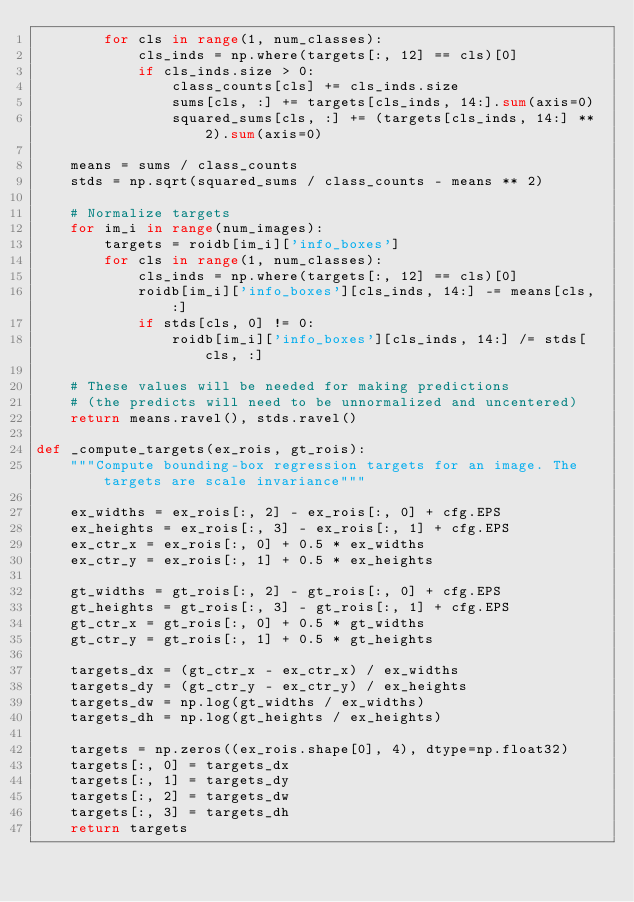<code> <loc_0><loc_0><loc_500><loc_500><_Python_>        for cls in range(1, num_classes):
            cls_inds = np.where(targets[:, 12] == cls)[0]
            if cls_inds.size > 0:
                class_counts[cls] += cls_inds.size
                sums[cls, :] += targets[cls_inds, 14:].sum(axis=0)
                squared_sums[cls, :] += (targets[cls_inds, 14:] ** 2).sum(axis=0)

    means = sums / class_counts
    stds = np.sqrt(squared_sums / class_counts - means ** 2)

    # Normalize targets
    for im_i in range(num_images):
        targets = roidb[im_i]['info_boxes']
        for cls in range(1, num_classes):
            cls_inds = np.where(targets[:, 12] == cls)[0]
            roidb[im_i]['info_boxes'][cls_inds, 14:] -= means[cls, :]
            if stds[cls, 0] != 0:
                roidb[im_i]['info_boxes'][cls_inds, 14:] /= stds[cls, :]

    # These values will be needed for making predictions
    # (the predicts will need to be unnormalized and uncentered)
    return means.ravel(), stds.ravel()

def _compute_targets(ex_rois, gt_rois):
    """Compute bounding-box regression targets for an image. The targets are scale invariance"""

    ex_widths = ex_rois[:, 2] - ex_rois[:, 0] + cfg.EPS
    ex_heights = ex_rois[:, 3] - ex_rois[:, 1] + cfg.EPS
    ex_ctr_x = ex_rois[:, 0] + 0.5 * ex_widths
    ex_ctr_y = ex_rois[:, 1] + 0.5 * ex_heights

    gt_widths = gt_rois[:, 2] - gt_rois[:, 0] + cfg.EPS
    gt_heights = gt_rois[:, 3] - gt_rois[:, 1] + cfg.EPS
    gt_ctr_x = gt_rois[:, 0] + 0.5 * gt_widths
    gt_ctr_y = gt_rois[:, 1] + 0.5 * gt_heights

    targets_dx = (gt_ctr_x - ex_ctr_x) / ex_widths
    targets_dy = (gt_ctr_y - ex_ctr_y) / ex_heights
    targets_dw = np.log(gt_widths / ex_widths)
    targets_dh = np.log(gt_heights / ex_heights)

    targets = np.zeros((ex_rois.shape[0], 4), dtype=np.float32)
    targets[:, 0] = targets_dx
    targets[:, 1] = targets_dy
    targets[:, 2] = targets_dw
    targets[:, 3] = targets_dh
    return targets
</code> 